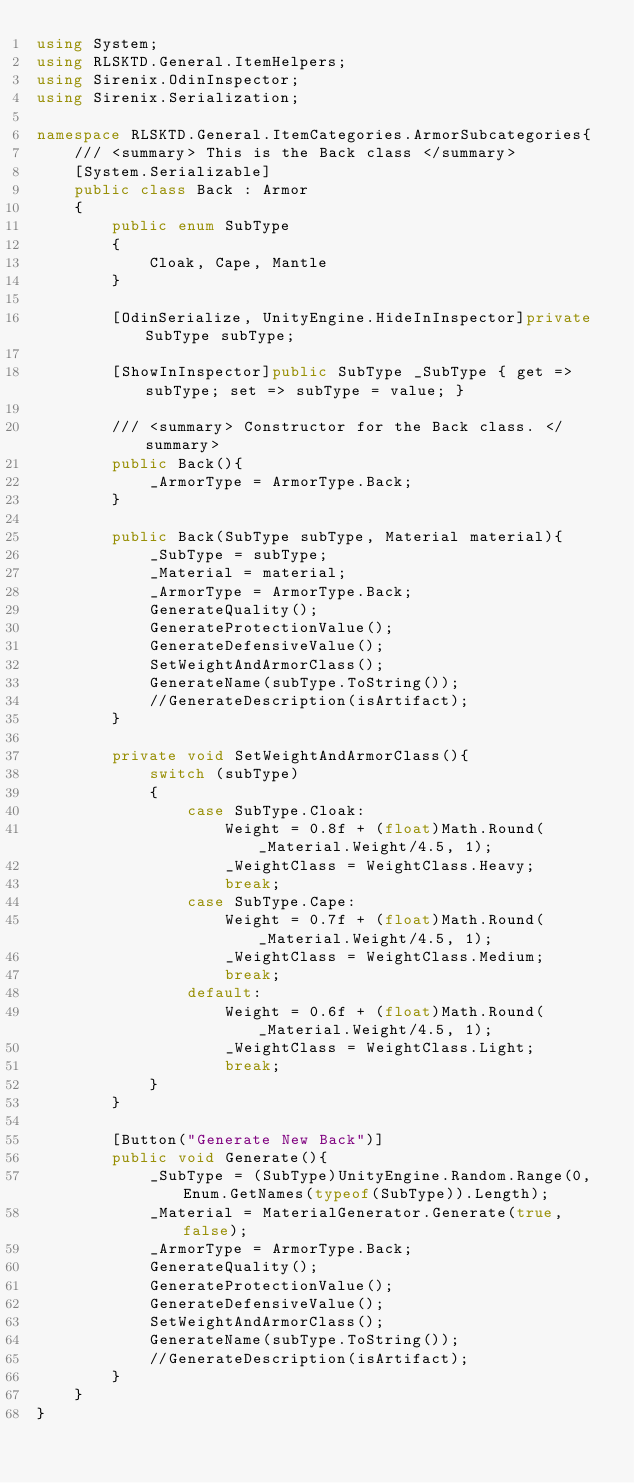<code> <loc_0><loc_0><loc_500><loc_500><_C#_>using System;
using RLSKTD.General.ItemHelpers;
using Sirenix.OdinInspector;
using Sirenix.Serialization;

namespace RLSKTD.General.ItemCategories.ArmorSubcategories{
    /// <summary> This is the Back class </summary>
    [System.Serializable]
    public class Back : Armor
    {
        public enum SubType
        {
            Cloak, Cape, Mantle
        }

        [OdinSerialize, UnityEngine.HideInInspector]private SubType subType;

        [ShowInInspector]public SubType _SubType { get => subType; set => subType = value; }

        /// <summary> Constructor for the Back class. </summary>
        public Back(){
            _ArmorType = ArmorType.Back;
        }

        public Back(SubType subType, Material material){
            _SubType = subType;
            _Material = material;
            _ArmorType = ArmorType.Back;
            GenerateQuality();
            GenerateProtectionValue();
            GenerateDefensiveValue();
            SetWeightAndArmorClass();
            GenerateName(subType.ToString());
            //GenerateDescription(isArtifact);
        }

        private void SetWeightAndArmorClass(){
            switch (subType)
            {
                case SubType.Cloak:
                    Weight = 0.8f + (float)Math.Round(_Material.Weight/4.5, 1);
                    _WeightClass = WeightClass.Heavy;
                    break;
                case SubType.Cape:
                    Weight = 0.7f + (float)Math.Round(_Material.Weight/4.5, 1);
                    _WeightClass = WeightClass.Medium;
                    break;
                default:
                    Weight = 0.6f + (float)Math.Round(_Material.Weight/4.5, 1);
                    _WeightClass = WeightClass.Light;
                    break;
            }
        }

        [Button("Generate New Back")]
        public void Generate(){
            _SubType = (SubType)UnityEngine.Random.Range(0, Enum.GetNames(typeof(SubType)).Length);
            _Material = MaterialGenerator.Generate(true, false);
            _ArmorType = ArmorType.Back;
            GenerateQuality();
            GenerateProtectionValue();
            GenerateDefensiveValue();
            SetWeightAndArmorClass();
            GenerateName(subType.ToString());
            //GenerateDescription(isArtifact);
        }
    }
}</code> 